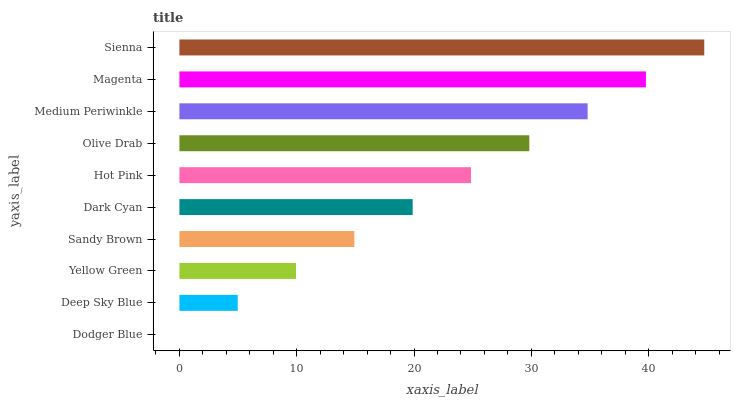Is Dodger Blue the minimum?
Answer yes or no. Yes. Is Sienna the maximum?
Answer yes or no. Yes. Is Deep Sky Blue the minimum?
Answer yes or no. No. Is Deep Sky Blue the maximum?
Answer yes or no. No. Is Deep Sky Blue greater than Dodger Blue?
Answer yes or no. Yes. Is Dodger Blue less than Deep Sky Blue?
Answer yes or no. Yes. Is Dodger Blue greater than Deep Sky Blue?
Answer yes or no. No. Is Deep Sky Blue less than Dodger Blue?
Answer yes or no. No. Is Hot Pink the high median?
Answer yes or no. Yes. Is Dark Cyan the low median?
Answer yes or no. Yes. Is Sienna the high median?
Answer yes or no. No. Is Hot Pink the low median?
Answer yes or no. No. 